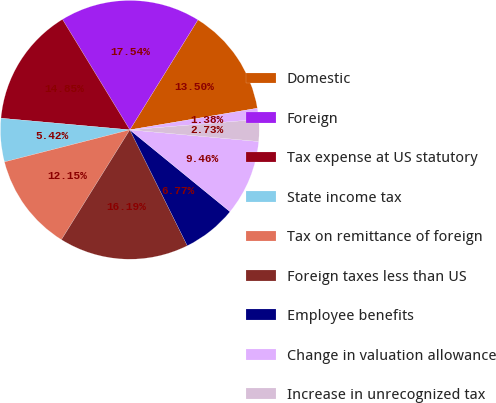<chart> <loc_0><loc_0><loc_500><loc_500><pie_chart><fcel>Domestic<fcel>Foreign<fcel>Tax expense at US statutory<fcel>State income tax<fcel>Tax on remittance of foreign<fcel>Foreign taxes less than US<fcel>Employee benefits<fcel>Change in valuation allowance<fcel>Increase in unrecognized tax<fcel>Release of unrecognized tax<nl><fcel>13.5%<fcel>17.54%<fcel>14.85%<fcel>5.42%<fcel>12.15%<fcel>16.19%<fcel>6.77%<fcel>9.46%<fcel>2.73%<fcel>1.38%<nl></chart> 